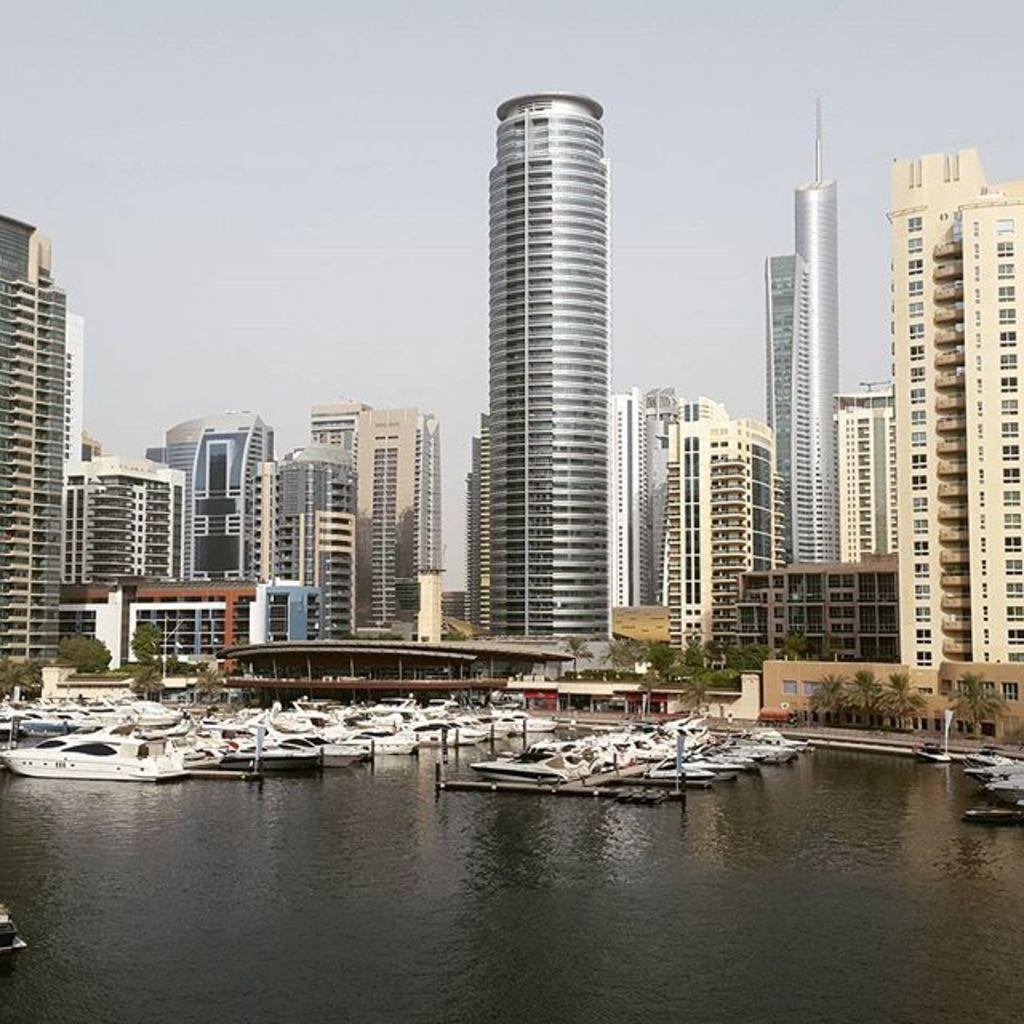What type of structures are visible in the image? The image contains buildings and skyscrapers. What is located at the bottom of the image? There is water at the bottom of the image. What can be seen floating on the water? Many boats are present on the water. What is visible at the top of the image? The sky is visible at the top of the image. Where is the library located in the image? There is no library mentioned or visible in the image. What type of boot can be seen on one of the boats in the image? There are no boots visible in the image; only boats are present on the water. 